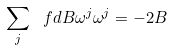Convert formula to latex. <formula><loc_0><loc_0><loc_500><loc_500>\sum _ { j } \ f d { B } { \omega ^ { j } } \omega ^ { j } = - 2 B</formula> 